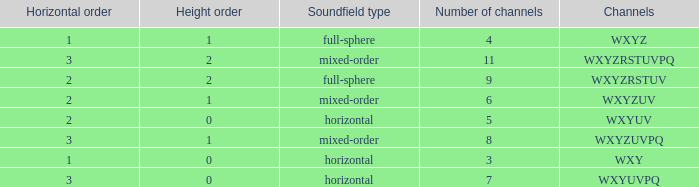If the channels is wxyzuv, what is the number of channels? 6.0. Parse the full table. {'header': ['Horizontal order', 'Height order', 'Soundfield type', 'Number of channels', 'Channels'], 'rows': [['1', '1', 'full-sphere', '4', 'WXYZ'], ['3', '2', 'mixed-order', '11', 'WXYZRSTUVPQ'], ['2', '2', 'full-sphere', '9', 'WXYZRSTUV'], ['2', '1', 'mixed-order', '6', 'WXYZUV'], ['2', '0', 'horizontal', '5', 'WXYUV'], ['3', '1', 'mixed-order', '8', 'WXYZUVPQ'], ['1', '0', 'horizontal', '3', 'WXY'], ['3', '0', 'horizontal', '7', 'WXYUVPQ']]} 